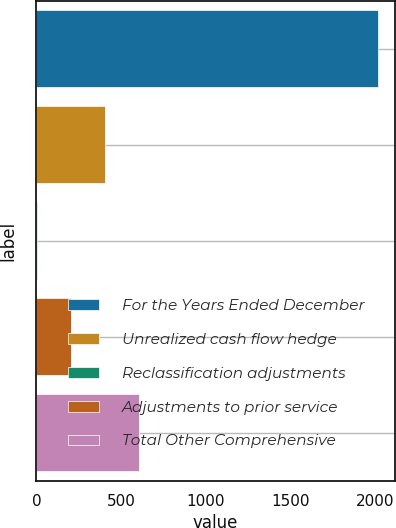<chart> <loc_0><loc_0><loc_500><loc_500><bar_chart><fcel>For the Years Ended December<fcel>Unrealized cash flow hedge<fcel>Reclassification adjustments<fcel>Adjustments to prior service<fcel>Total Other Comprehensive<nl><fcel>2013<fcel>405.32<fcel>3.4<fcel>204.36<fcel>606.28<nl></chart> 